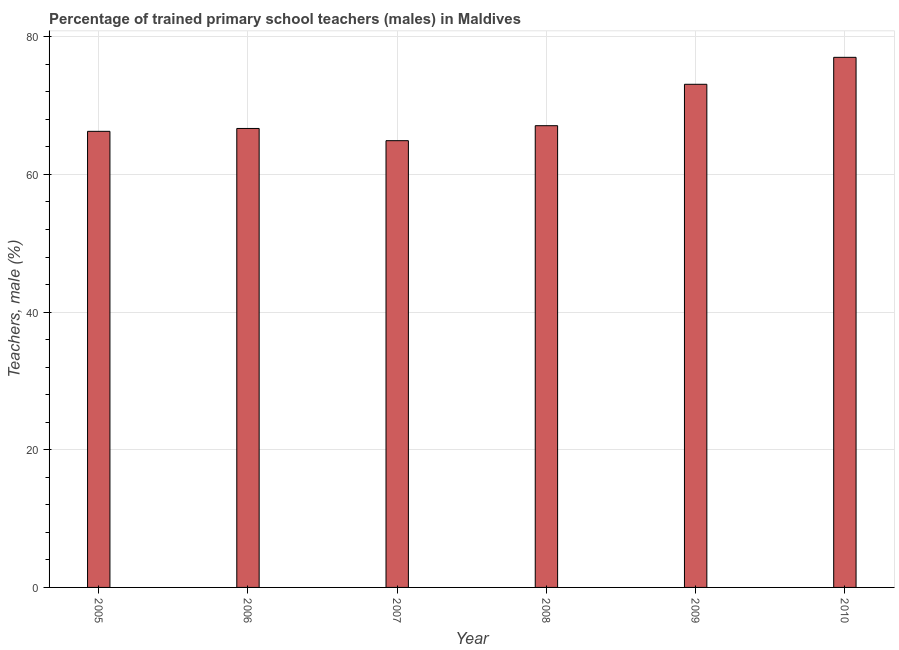What is the title of the graph?
Your answer should be very brief. Percentage of trained primary school teachers (males) in Maldives. What is the label or title of the Y-axis?
Your answer should be very brief. Teachers, male (%). What is the percentage of trained male teachers in 2010?
Offer a terse response. 77.02. Across all years, what is the maximum percentage of trained male teachers?
Provide a short and direct response. 77.02. Across all years, what is the minimum percentage of trained male teachers?
Provide a short and direct response. 64.91. In which year was the percentage of trained male teachers minimum?
Offer a very short reply. 2007. What is the sum of the percentage of trained male teachers?
Your response must be concise. 415.05. What is the difference between the percentage of trained male teachers in 2008 and 2009?
Provide a short and direct response. -6.01. What is the average percentage of trained male teachers per year?
Offer a very short reply. 69.17. What is the median percentage of trained male teachers?
Your answer should be compact. 66.88. Do a majority of the years between 2009 and 2005 (inclusive) have percentage of trained male teachers greater than 76 %?
Your response must be concise. Yes. What is the ratio of the percentage of trained male teachers in 2007 to that in 2009?
Ensure brevity in your answer.  0.89. Is the percentage of trained male teachers in 2007 less than that in 2010?
Your answer should be very brief. Yes. Is the difference between the percentage of trained male teachers in 2008 and 2009 greater than the difference between any two years?
Your response must be concise. No. What is the difference between the highest and the second highest percentage of trained male teachers?
Your answer should be very brief. 3.92. What is the difference between the highest and the lowest percentage of trained male teachers?
Make the answer very short. 12.11. In how many years, is the percentage of trained male teachers greater than the average percentage of trained male teachers taken over all years?
Your answer should be very brief. 2. How many bars are there?
Your answer should be very brief. 6. How many years are there in the graph?
Give a very brief answer. 6. What is the difference between two consecutive major ticks on the Y-axis?
Give a very brief answer. 20. Are the values on the major ticks of Y-axis written in scientific E-notation?
Give a very brief answer. No. What is the Teachers, male (%) of 2005?
Give a very brief answer. 66.27. What is the Teachers, male (%) in 2006?
Keep it short and to the point. 66.68. What is the Teachers, male (%) of 2007?
Make the answer very short. 64.91. What is the Teachers, male (%) of 2008?
Your answer should be very brief. 67.08. What is the Teachers, male (%) in 2009?
Your response must be concise. 73.1. What is the Teachers, male (%) in 2010?
Make the answer very short. 77.02. What is the difference between the Teachers, male (%) in 2005 and 2006?
Keep it short and to the point. -0.42. What is the difference between the Teachers, male (%) in 2005 and 2007?
Provide a short and direct response. 1.36. What is the difference between the Teachers, male (%) in 2005 and 2008?
Offer a terse response. -0.82. What is the difference between the Teachers, male (%) in 2005 and 2009?
Give a very brief answer. -6.83. What is the difference between the Teachers, male (%) in 2005 and 2010?
Provide a short and direct response. -10.75. What is the difference between the Teachers, male (%) in 2006 and 2007?
Keep it short and to the point. 1.77. What is the difference between the Teachers, male (%) in 2006 and 2008?
Give a very brief answer. -0.4. What is the difference between the Teachers, male (%) in 2006 and 2009?
Give a very brief answer. -6.42. What is the difference between the Teachers, male (%) in 2006 and 2010?
Provide a short and direct response. -10.34. What is the difference between the Teachers, male (%) in 2007 and 2008?
Provide a short and direct response. -2.18. What is the difference between the Teachers, male (%) in 2007 and 2009?
Offer a terse response. -8.19. What is the difference between the Teachers, male (%) in 2007 and 2010?
Provide a short and direct response. -12.11. What is the difference between the Teachers, male (%) in 2008 and 2009?
Keep it short and to the point. -6.02. What is the difference between the Teachers, male (%) in 2008 and 2010?
Give a very brief answer. -9.93. What is the difference between the Teachers, male (%) in 2009 and 2010?
Make the answer very short. -3.92. What is the ratio of the Teachers, male (%) in 2005 to that in 2009?
Your answer should be compact. 0.91. What is the ratio of the Teachers, male (%) in 2005 to that in 2010?
Offer a terse response. 0.86. What is the ratio of the Teachers, male (%) in 2006 to that in 2008?
Keep it short and to the point. 0.99. What is the ratio of the Teachers, male (%) in 2006 to that in 2009?
Ensure brevity in your answer.  0.91. What is the ratio of the Teachers, male (%) in 2006 to that in 2010?
Provide a succinct answer. 0.87. What is the ratio of the Teachers, male (%) in 2007 to that in 2009?
Make the answer very short. 0.89. What is the ratio of the Teachers, male (%) in 2007 to that in 2010?
Your response must be concise. 0.84. What is the ratio of the Teachers, male (%) in 2008 to that in 2009?
Provide a succinct answer. 0.92. What is the ratio of the Teachers, male (%) in 2008 to that in 2010?
Your answer should be very brief. 0.87. What is the ratio of the Teachers, male (%) in 2009 to that in 2010?
Your response must be concise. 0.95. 